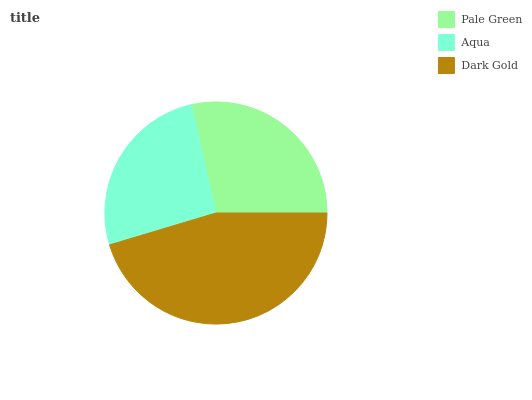Is Aqua the minimum?
Answer yes or no. Yes. Is Dark Gold the maximum?
Answer yes or no. Yes. Is Dark Gold the minimum?
Answer yes or no. No. Is Aqua the maximum?
Answer yes or no. No. Is Dark Gold greater than Aqua?
Answer yes or no. Yes. Is Aqua less than Dark Gold?
Answer yes or no. Yes. Is Aqua greater than Dark Gold?
Answer yes or no. No. Is Dark Gold less than Aqua?
Answer yes or no. No. Is Pale Green the high median?
Answer yes or no. Yes. Is Pale Green the low median?
Answer yes or no. Yes. Is Dark Gold the high median?
Answer yes or no. No. Is Dark Gold the low median?
Answer yes or no. No. 